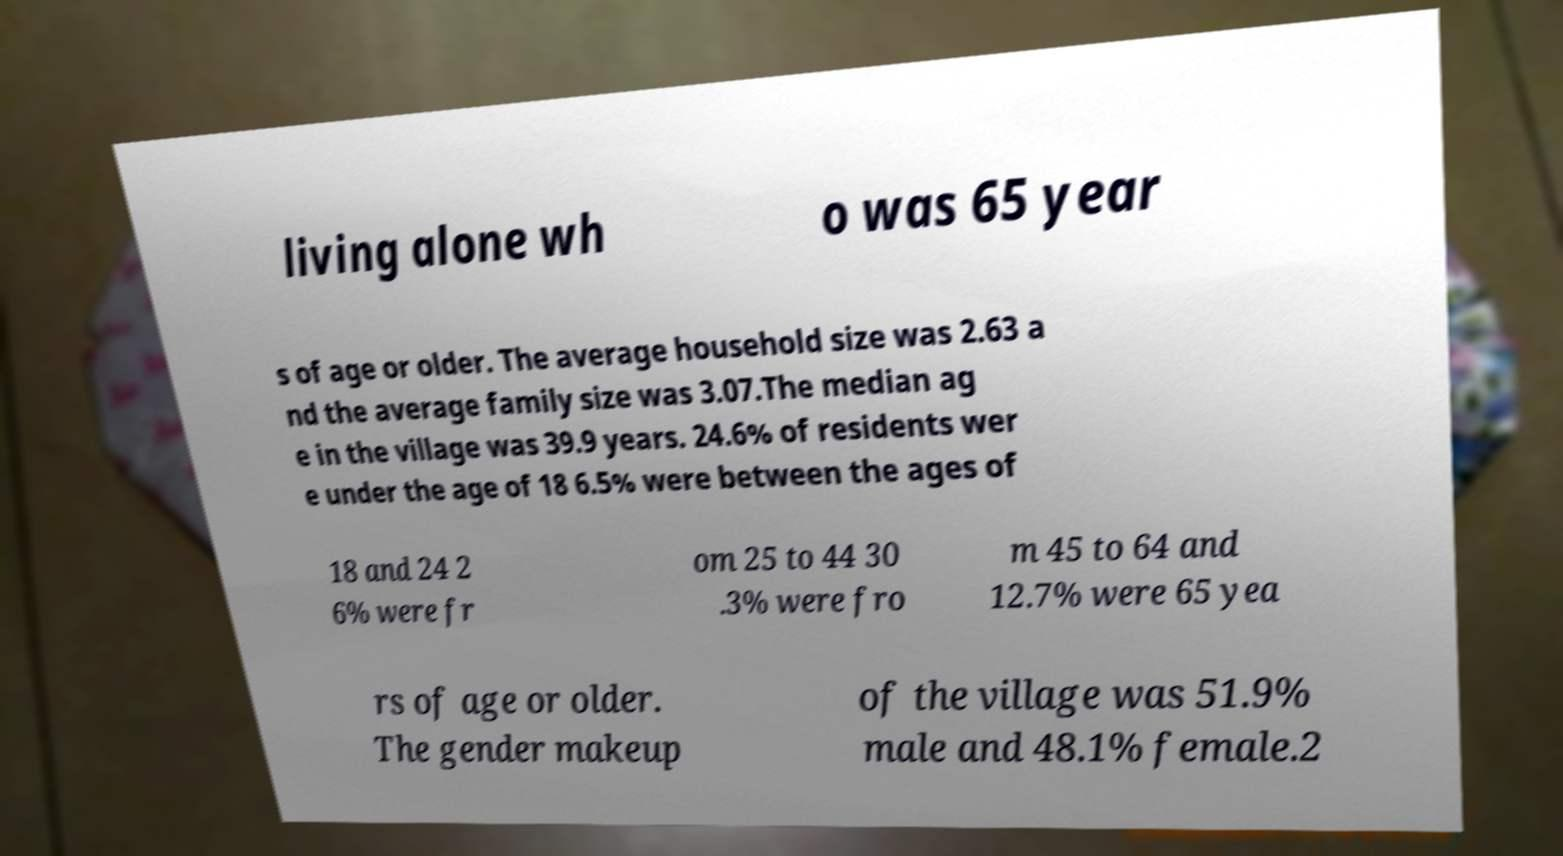Could you extract and type out the text from this image? living alone wh o was 65 year s of age or older. The average household size was 2.63 a nd the average family size was 3.07.The median ag e in the village was 39.9 years. 24.6% of residents wer e under the age of 18 6.5% were between the ages of 18 and 24 2 6% were fr om 25 to 44 30 .3% were fro m 45 to 64 and 12.7% were 65 yea rs of age or older. The gender makeup of the village was 51.9% male and 48.1% female.2 